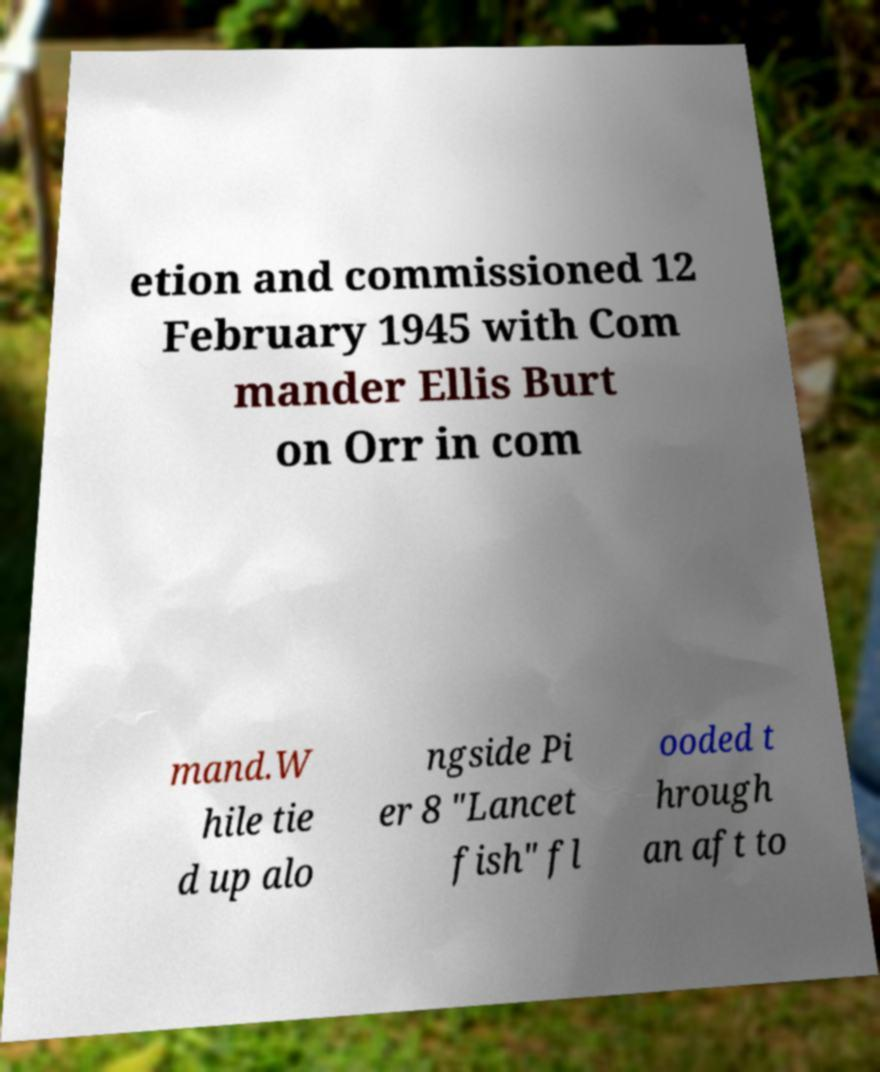Please read and relay the text visible in this image. What does it say? etion and commissioned 12 February 1945 with Com mander Ellis Burt on Orr in com mand.W hile tie d up alo ngside Pi er 8 "Lancet fish" fl ooded t hrough an aft to 